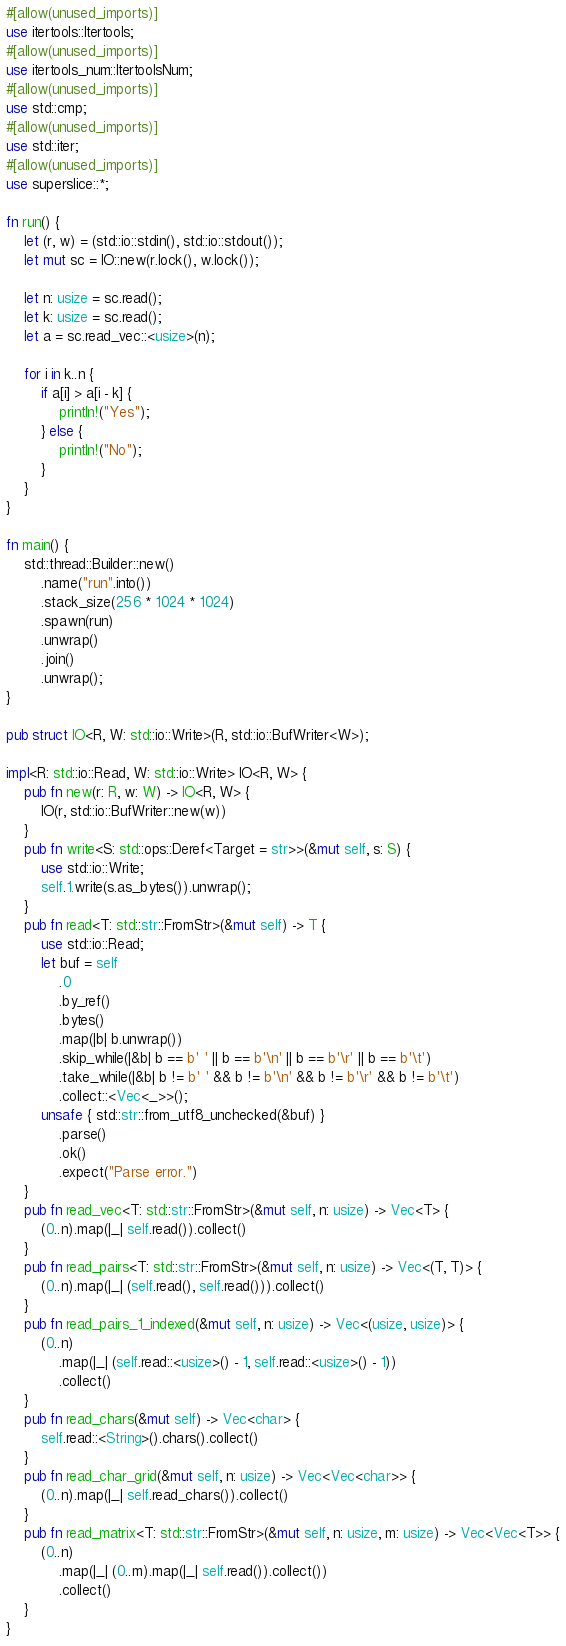Convert code to text. <code><loc_0><loc_0><loc_500><loc_500><_Rust_>#[allow(unused_imports)]
use itertools::Itertools;
#[allow(unused_imports)]
use itertools_num::ItertoolsNum;
#[allow(unused_imports)]
use std::cmp;
#[allow(unused_imports)]
use std::iter;
#[allow(unused_imports)]
use superslice::*;

fn run() {
    let (r, w) = (std::io::stdin(), std::io::stdout());
    let mut sc = IO::new(r.lock(), w.lock());

    let n: usize = sc.read();
    let k: usize = sc.read();
    let a = sc.read_vec::<usize>(n);

    for i in k..n {
        if a[i] > a[i - k] {
            println!("Yes");
        } else {
            println!("No");
        }
    }
}

fn main() {
    std::thread::Builder::new()
        .name("run".into())
        .stack_size(256 * 1024 * 1024)
        .spawn(run)
        .unwrap()
        .join()
        .unwrap();
}

pub struct IO<R, W: std::io::Write>(R, std::io::BufWriter<W>);

impl<R: std::io::Read, W: std::io::Write> IO<R, W> {
    pub fn new(r: R, w: W) -> IO<R, W> {
        IO(r, std::io::BufWriter::new(w))
    }
    pub fn write<S: std::ops::Deref<Target = str>>(&mut self, s: S) {
        use std::io::Write;
        self.1.write(s.as_bytes()).unwrap();
    }
    pub fn read<T: std::str::FromStr>(&mut self) -> T {
        use std::io::Read;
        let buf = self
            .0
            .by_ref()
            .bytes()
            .map(|b| b.unwrap())
            .skip_while(|&b| b == b' ' || b == b'\n' || b == b'\r' || b == b'\t')
            .take_while(|&b| b != b' ' && b != b'\n' && b != b'\r' && b != b'\t')
            .collect::<Vec<_>>();
        unsafe { std::str::from_utf8_unchecked(&buf) }
            .parse()
            .ok()
            .expect("Parse error.")
    }
    pub fn read_vec<T: std::str::FromStr>(&mut self, n: usize) -> Vec<T> {
        (0..n).map(|_| self.read()).collect()
    }
    pub fn read_pairs<T: std::str::FromStr>(&mut self, n: usize) -> Vec<(T, T)> {
        (0..n).map(|_| (self.read(), self.read())).collect()
    }
    pub fn read_pairs_1_indexed(&mut self, n: usize) -> Vec<(usize, usize)> {
        (0..n)
            .map(|_| (self.read::<usize>() - 1, self.read::<usize>() - 1))
            .collect()
    }
    pub fn read_chars(&mut self) -> Vec<char> {
        self.read::<String>().chars().collect()
    }
    pub fn read_char_grid(&mut self, n: usize) -> Vec<Vec<char>> {
        (0..n).map(|_| self.read_chars()).collect()
    }
    pub fn read_matrix<T: std::str::FromStr>(&mut self, n: usize, m: usize) -> Vec<Vec<T>> {
        (0..n)
            .map(|_| (0..m).map(|_| self.read()).collect())
            .collect()
    }
}
</code> 